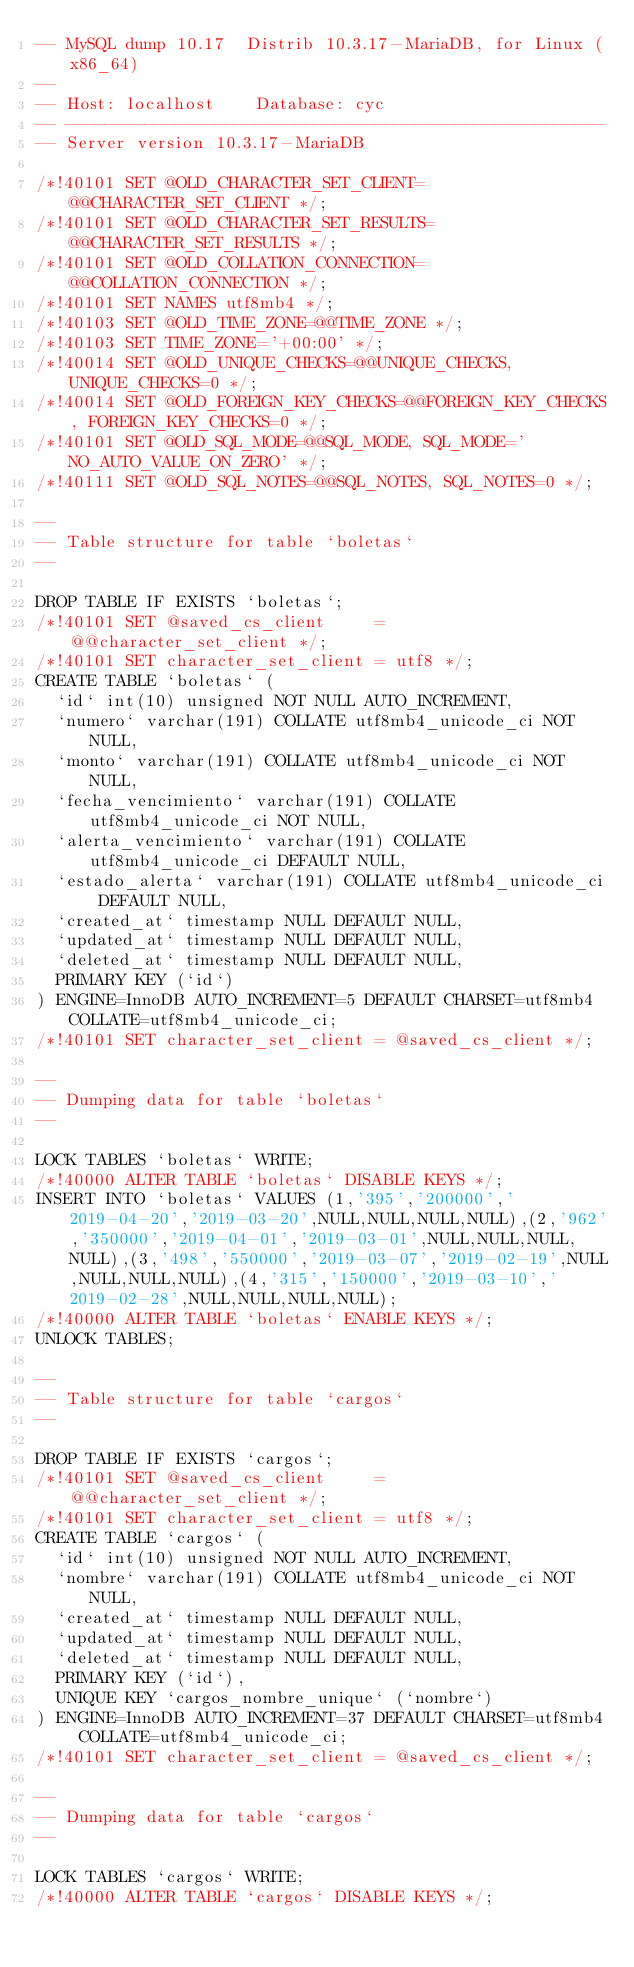<code> <loc_0><loc_0><loc_500><loc_500><_SQL_>-- MySQL dump 10.17  Distrib 10.3.17-MariaDB, for Linux (x86_64)
--
-- Host: localhost    Database: cyc
-- ------------------------------------------------------
-- Server version	10.3.17-MariaDB

/*!40101 SET @OLD_CHARACTER_SET_CLIENT=@@CHARACTER_SET_CLIENT */;
/*!40101 SET @OLD_CHARACTER_SET_RESULTS=@@CHARACTER_SET_RESULTS */;
/*!40101 SET @OLD_COLLATION_CONNECTION=@@COLLATION_CONNECTION */;
/*!40101 SET NAMES utf8mb4 */;
/*!40103 SET @OLD_TIME_ZONE=@@TIME_ZONE */;
/*!40103 SET TIME_ZONE='+00:00' */;
/*!40014 SET @OLD_UNIQUE_CHECKS=@@UNIQUE_CHECKS, UNIQUE_CHECKS=0 */;
/*!40014 SET @OLD_FOREIGN_KEY_CHECKS=@@FOREIGN_KEY_CHECKS, FOREIGN_KEY_CHECKS=0 */;
/*!40101 SET @OLD_SQL_MODE=@@SQL_MODE, SQL_MODE='NO_AUTO_VALUE_ON_ZERO' */;
/*!40111 SET @OLD_SQL_NOTES=@@SQL_NOTES, SQL_NOTES=0 */;

--
-- Table structure for table `boletas`
--

DROP TABLE IF EXISTS `boletas`;
/*!40101 SET @saved_cs_client     = @@character_set_client */;
/*!40101 SET character_set_client = utf8 */;
CREATE TABLE `boletas` (
  `id` int(10) unsigned NOT NULL AUTO_INCREMENT,
  `numero` varchar(191) COLLATE utf8mb4_unicode_ci NOT NULL,
  `monto` varchar(191) COLLATE utf8mb4_unicode_ci NOT NULL,
  `fecha_vencimiento` varchar(191) COLLATE utf8mb4_unicode_ci NOT NULL,
  `alerta_vencimiento` varchar(191) COLLATE utf8mb4_unicode_ci DEFAULT NULL,
  `estado_alerta` varchar(191) COLLATE utf8mb4_unicode_ci DEFAULT NULL,
  `created_at` timestamp NULL DEFAULT NULL,
  `updated_at` timestamp NULL DEFAULT NULL,
  `deleted_at` timestamp NULL DEFAULT NULL,
  PRIMARY KEY (`id`)
) ENGINE=InnoDB AUTO_INCREMENT=5 DEFAULT CHARSET=utf8mb4 COLLATE=utf8mb4_unicode_ci;
/*!40101 SET character_set_client = @saved_cs_client */;

--
-- Dumping data for table `boletas`
--

LOCK TABLES `boletas` WRITE;
/*!40000 ALTER TABLE `boletas` DISABLE KEYS */;
INSERT INTO `boletas` VALUES (1,'395','200000','2019-04-20','2019-03-20',NULL,NULL,NULL,NULL),(2,'962','350000','2019-04-01','2019-03-01',NULL,NULL,NULL,NULL),(3,'498','550000','2019-03-07','2019-02-19',NULL,NULL,NULL,NULL),(4,'315','150000','2019-03-10','2019-02-28',NULL,NULL,NULL,NULL);
/*!40000 ALTER TABLE `boletas` ENABLE KEYS */;
UNLOCK TABLES;

--
-- Table structure for table `cargos`
--

DROP TABLE IF EXISTS `cargos`;
/*!40101 SET @saved_cs_client     = @@character_set_client */;
/*!40101 SET character_set_client = utf8 */;
CREATE TABLE `cargos` (
  `id` int(10) unsigned NOT NULL AUTO_INCREMENT,
  `nombre` varchar(191) COLLATE utf8mb4_unicode_ci NOT NULL,
  `created_at` timestamp NULL DEFAULT NULL,
  `updated_at` timestamp NULL DEFAULT NULL,
  `deleted_at` timestamp NULL DEFAULT NULL,
  PRIMARY KEY (`id`),
  UNIQUE KEY `cargos_nombre_unique` (`nombre`)
) ENGINE=InnoDB AUTO_INCREMENT=37 DEFAULT CHARSET=utf8mb4 COLLATE=utf8mb4_unicode_ci;
/*!40101 SET character_set_client = @saved_cs_client */;

--
-- Dumping data for table `cargos`
--

LOCK TABLES `cargos` WRITE;
/*!40000 ALTER TABLE `cargos` DISABLE KEYS */;</code> 